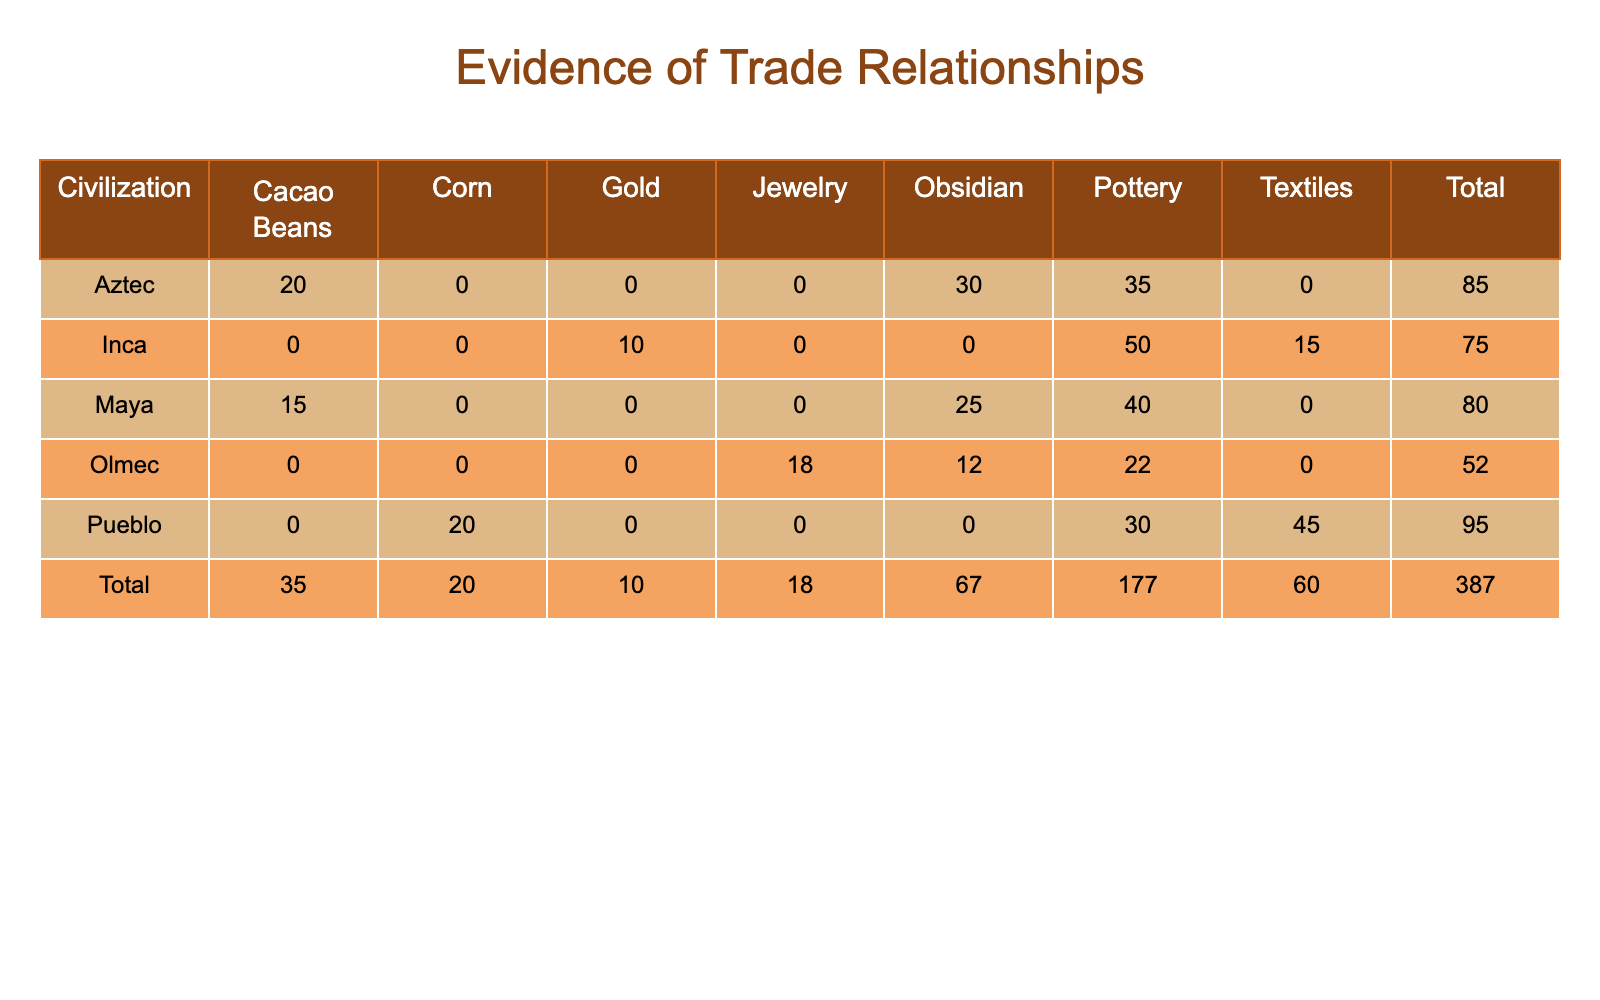What is the total frequency of pottery found in civilization? To find the total frequency of pottery, I will sum the values of pottery for all civilizations: Maya (40) + Aztec (35) + Inca (50) + Olmec (22) + Pueblo (30) = 177.
Answer: 177 Which civilization has the highest frequency of obsidian? By examining the obsidian values of each civilization, I see they are: Maya (25), Aztec (30), Olmec (12). The highest value is for the Aztec civilization with 30.
Answer: Aztec Is there any evidence of trade relationships with the Inca civilization based on the materials found? The Inca civilization has multiple materials found: Gold (10), Pottery (50), Textiles (15). The presence of these materials suggests interactions with nearby civilizations, indicating that there is evidence of trade relationships.
Answer: Yes What is the average frequency of cacao beans across the civilizations that have it? The civilizations with cacao beans are Maya (15) and Aztec (20). To find the average, I sum these values: 15 + 20 = 35, then divide by the number of civilizations with cacao beans (2): 35/2 = 17.5.
Answer: 17.5 How many total materials were found in the Pueblo civilization? In the Pueblo civilization, frequencies of materials are: Textiles (45), Pottery (30), Corn (20). To find the total, I sum these frequencies: 45 + 30 + 20 = 95.
Answer: 95 Which civilization has the least frequency of textiles? Only the Inca civilization has textiles (15). Therefore, comparing to other civilizations, the Inca has the least frequency of textiles since other civilizations do not have any.
Answer: Inca Does the Olmec civilization have a higher total material frequency than the Inca civilization? The total frequency for Olmec is calculated as follows: Obsidian (12) + Pottery (22) + Jewelry (18) = 52. For the Inca: Gold (10) + Pottery (50) + Textiles (15) = 75. Since 52 (Olmec) is less than 75 (Inca), the Olmec civilization does not have a higher total.
Answer: No What is the difference in frequency between the highest and lowest pottery findings among civilizations? The highest pottery frequency is from the Inca (50) and the lowest is from the Olmec (22). The difference is calculated by subtracting the lower from the higher: 50 - 22 = 28.
Answer: 28 Which civilization shows evidence of trade with cacao beans but not textiles? The Maya civilization has cacao beans (15) but does not have textiles. The Aztec civilization has cacao beans (20) as well but also does not have textiles. Inca has textiles and does not have cacao beans. Therefore, the Maya and the Aztec show evidence of trade with cacao beans while the Inca does not.
Answer: Maya, Aztec 